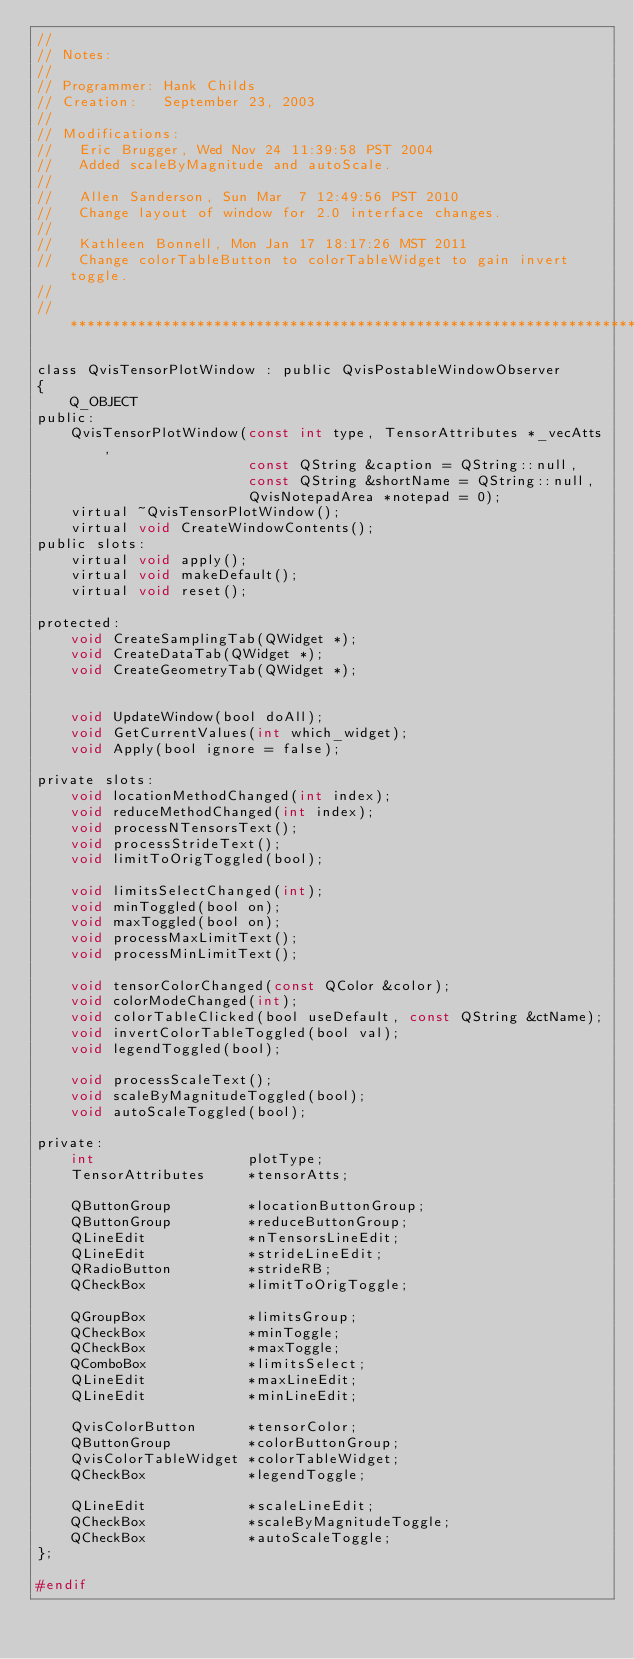Convert code to text. <code><loc_0><loc_0><loc_500><loc_500><_C_>//
// Notes:      
//
// Programmer: Hank Childs
// Creation:   September 23, 2003
//
// Modifications:
//   Eric Brugger, Wed Nov 24 11:39:58 PST 2004
//   Added scaleByMagnitude and autoScale.
//
//   Allen Sanderson, Sun Mar  7 12:49:56 PST 2010
//   Change layout of window for 2.0 interface changes.
//
//   Kathleen Bonnell, Mon Jan 17 18:17:26 MST 2011
//   Change colorTableButton to colorTableWidget to gain invert toggle.
//
// ****************************************************************************

class QvisTensorPlotWindow : public QvisPostableWindowObserver
{
    Q_OBJECT
public:
    QvisTensorPlotWindow(const int type, TensorAttributes *_vecAtts,
                         const QString &caption = QString::null,
                         const QString &shortName = QString::null,
                         QvisNotepadArea *notepad = 0);
    virtual ~QvisTensorPlotWindow();
    virtual void CreateWindowContents();
public slots:
    virtual void apply();
    virtual void makeDefault();
    virtual void reset();

protected:
    void CreateSamplingTab(QWidget *);
    void CreateDataTab(QWidget *);
    void CreateGeometryTab(QWidget *);


    void UpdateWindow(bool doAll);
    void GetCurrentValues(int which_widget);
    void Apply(bool ignore = false);

private slots:
    void locationMethodChanged(int index);
    void reduceMethodChanged(int index);
    void processNTensorsText();
    void processStrideText();
    void limitToOrigToggled(bool);

    void limitsSelectChanged(int);
    void minToggled(bool on);
    void maxToggled(bool on);
    void processMaxLimitText();
    void processMinLimitText();

    void tensorColorChanged(const QColor &color);
    void colorModeChanged(int);
    void colorTableClicked(bool useDefault, const QString &ctName);
    void invertColorTableToggled(bool val);
    void legendToggled(bool);

    void processScaleText();
    void scaleByMagnitudeToggled(bool);
    void autoScaleToggled(bool);

private:
    int                  plotType;
    TensorAttributes     *tensorAtts;

    QButtonGroup         *locationButtonGroup;
    QButtonGroup         *reduceButtonGroup;
    QLineEdit            *nTensorsLineEdit;
    QLineEdit            *strideLineEdit;
    QRadioButton         *strideRB;
    QCheckBox            *limitToOrigToggle;

    QGroupBox            *limitsGroup;
    QCheckBox            *minToggle;
    QCheckBox            *maxToggle;
    QComboBox            *limitsSelect;
    QLineEdit            *maxLineEdit;
    QLineEdit            *minLineEdit;

    QvisColorButton      *tensorColor;
    QButtonGroup         *colorButtonGroup; 
    QvisColorTableWidget *colorTableWidget;
    QCheckBox            *legendToggle;

    QLineEdit            *scaleLineEdit;
    QCheckBox            *scaleByMagnitudeToggle;
    QCheckBox            *autoScaleToggle;
};

#endif
</code> 